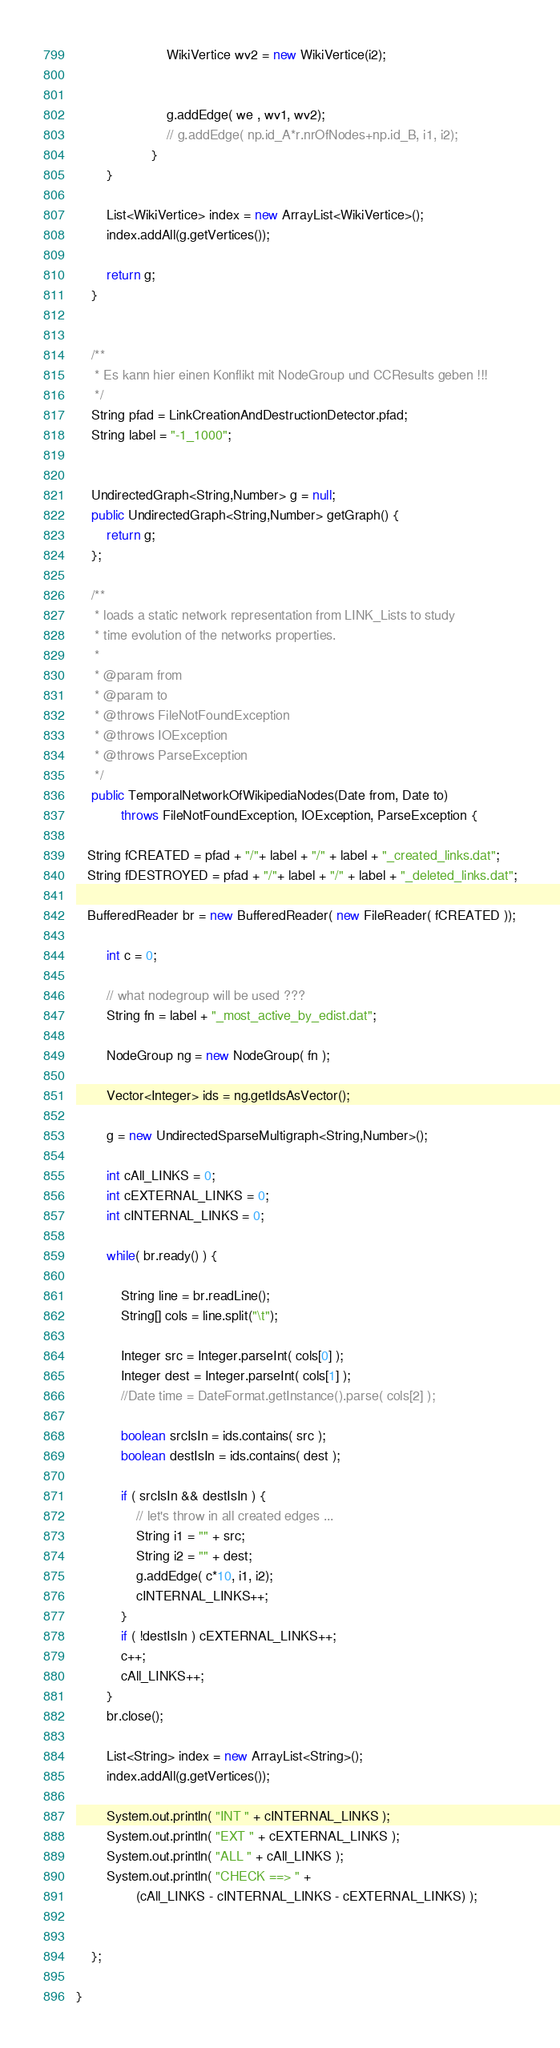<code> <loc_0><loc_0><loc_500><loc_500><_Java_>                        WikiVertice wv2 = new WikiVertice(i2);


                        g.addEdge( we , wv1, wv2);
                        // g.addEdge( np.id_A*r.nrOfNodes+np.id_B, i1, i2);
                    }
		}

		List<WikiVertice> index = new ArrayList<WikiVertice>();
		index.addAll(g.getVertices());

		return g;
    }


    /**
     * Es kann hier einen Konflikt mit NodeGroup und CCResults geben !!!
     */
    String pfad = LinkCreationAndDestructionDetector.pfad;
    String label = "-1_1000";


    UndirectedGraph<String,Number> g = null;
    public UndirectedGraph<String,Number> getGraph() {
        return g;
    };

    /**
     * loads a static network representation from LINK_Lists to study 
     * time evolution of the networks properties.
     * 
     * @param from
     * @param to
     * @throws FileNotFoundException
     * @throws IOException
     * @throws ParseException 
     */
    public TemporalNetworkOfWikipediaNodes(Date from, Date to) 
            throws FileNotFoundException, IOException, ParseException {
        
   String fCREATED = pfad + "/"+ label + "/" + label + "_created_links.dat";
   String fDESTROYED = pfad + "/"+ label + "/" + label + "_deleted_links.dat";

   BufferedReader br = new BufferedReader( new FileReader( fCREATED ));
   
        int c = 0;

        // what nodegroup will be used ???
        String fn = label + "_most_active_by_edist.dat";
        
        NodeGroup ng = new NodeGroup( fn );

        Vector<Integer> ids = ng.getIdsAsVector();

        g = new UndirectedSparseMultigraph<String,Number>();

        int cAll_LINKS = 0;
        int cEXTERNAL_LINKS = 0;
        int cINTERNAL_LINKS = 0;

        while( br.ready() ) {

            String line = br.readLine();
            String[] cols = line.split("\t");

            Integer src = Integer.parseInt( cols[0] );
            Integer dest = Integer.parseInt( cols[1] );
            //Date time = DateFormat.getInstance().parse( cols[2] );

            boolean srcIsIn = ids.contains( src );
            boolean destIsIn = ids.contains( dest );

            if ( srcIsIn && destIsIn ) {
                // let's throw in all created edges ...
                String i1 = "" + src;
                String i2 = "" + dest;
                g.addEdge( c*10, i1, i2);
                cINTERNAL_LINKS++;
            }
            if ( !destIsIn ) cEXTERNAL_LINKS++;
            c++;
            cAll_LINKS++;
        }
        br.close();

        List<String> index = new ArrayList<String>();
        index.addAll(g.getVertices());

        System.out.println( "INT " + cINTERNAL_LINKS );
        System.out.println( "EXT " + cEXTERNAL_LINKS );
        System.out.println( "ALL " + cAll_LINKS );
        System.out.println( "CHECK ==> " + 
                (cAll_LINKS - cINTERNAL_LINKS - cEXTERNAL_LINKS) );


    };

}
</code> 